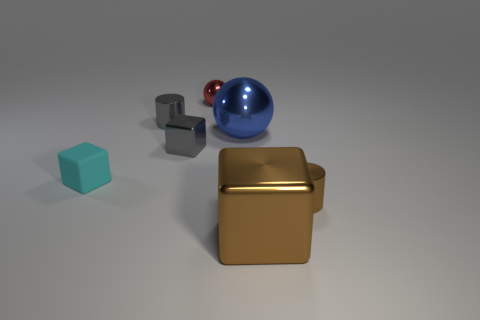Add 2 red shiny cylinders. How many objects exist? 9 Subtract all cubes. How many objects are left? 4 Subtract 0 purple balls. How many objects are left? 7 Subtract all big rubber cubes. Subtract all tiny brown metal things. How many objects are left? 6 Add 2 gray metallic cylinders. How many gray metallic cylinders are left? 3 Add 1 large gray matte blocks. How many large gray matte blocks exist? 1 